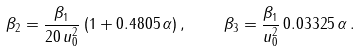Convert formula to latex. <formula><loc_0><loc_0><loc_500><loc_500>\beta _ { 2 } = \frac { \beta _ { 1 } } { 2 0 \, u _ { 0 } ^ { 2 } } \, ( 1 + 0 . 4 8 0 5 \, \alpha ) \, , \quad \beta _ { 3 } = \frac { \beta _ { 1 } } { u _ { 0 } ^ { 2 } } \, 0 . 0 3 3 2 5 \, \alpha \, .</formula> 